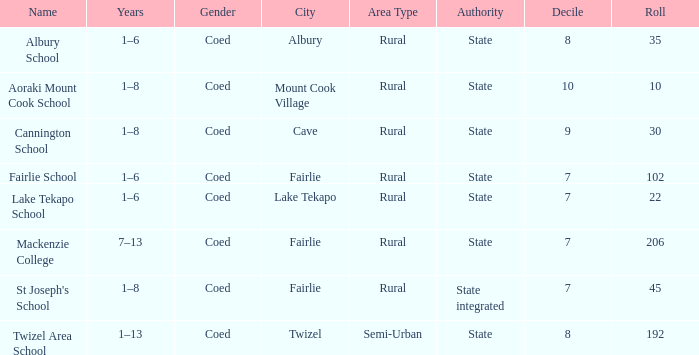What area is named Mackenzie college? Fairlie. Write the full table. {'header': ['Name', 'Years', 'Gender', 'City', 'Area Type', 'Authority', 'Decile', 'Roll'], 'rows': [['Albury School', '1–6', 'Coed', 'Albury', 'Rural', 'State', '8', '35'], ['Aoraki Mount Cook School', '1–8', 'Coed', 'Mount Cook Village', 'Rural', 'State', '10', '10'], ['Cannington School', '1–8', 'Coed', 'Cave', 'Rural', 'State', '9', '30'], ['Fairlie School', '1–6', 'Coed', 'Fairlie', 'Rural', 'State', '7', '102'], ['Lake Tekapo School', '1–6', 'Coed', 'Lake Tekapo', 'Rural', 'State', '7', '22'], ['Mackenzie College', '7–13', 'Coed', 'Fairlie', 'Rural', 'State', '7', '206'], ["St Joseph's School", '1–8', 'Coed', 'Fairlie', 'Rural', 'State integrated', '7', '45'], ['Twizel Area School', '1–13', 'Coed', 'Twizel', 'Semi-Urban', 'State', '8', '192']]} 